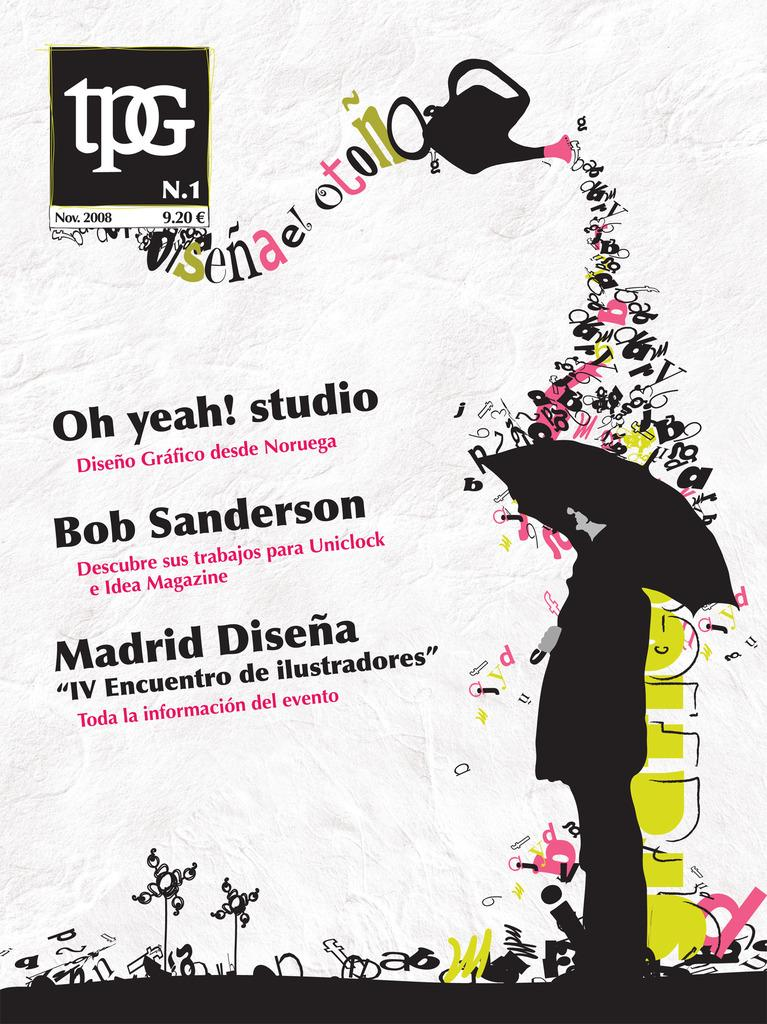What is featured in the image? There is a poster in the image. What can be seen on the right side of the poster? There is a cartoon of a person on the right side of the poster. What is the person in the cartoon holding? A: The person in the cartoon is holding an umbrella. What is present in the middle of the poster? There is some text in the middle of the poster. What type of tank can be seen in the image? There is no tank present in the image; it features a poster with a cartoon of a person holding an umbrella and some text. What is the person in the cartoon smiling about? The person in the cartoon does not have a visible expression, so it cannot be determined if they are smiling or not. 